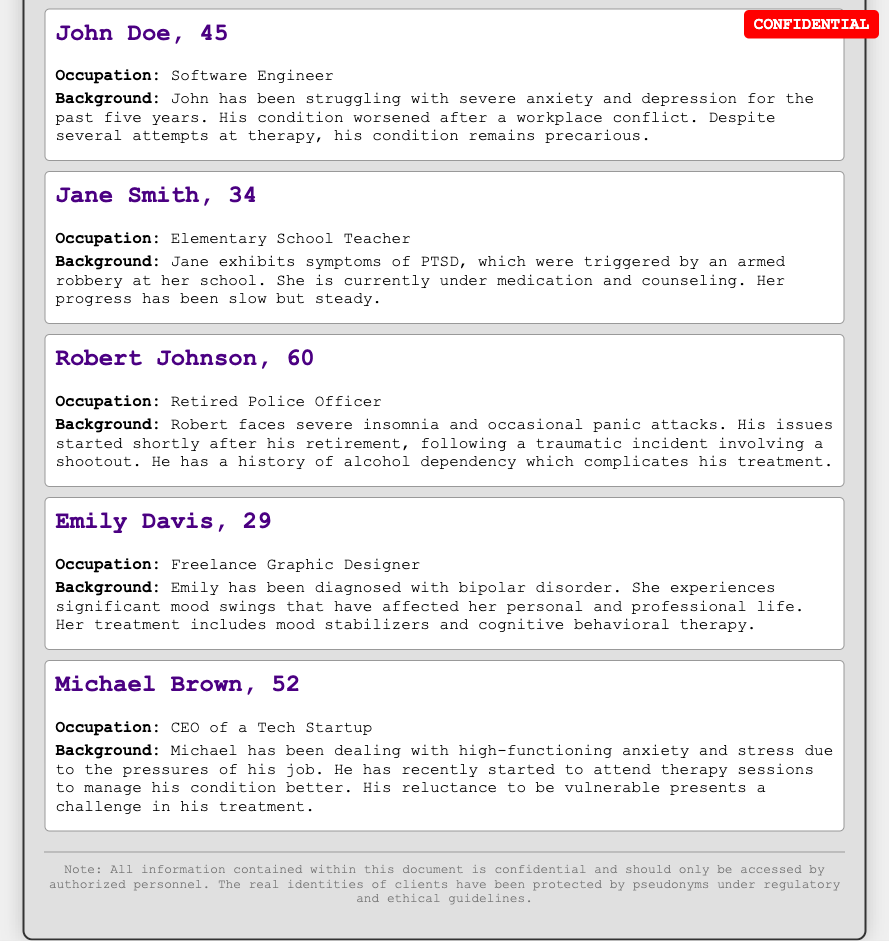what is the occupation of John Doe? John Doe's occupation is listed in the document as a Software Engineer.
Answer: Software Engineer how old is Jane Smith? The document states that Jane Smith is 34 years old.
Answer: 34 what mental health diagnosis does Emily Davis have? The document reveals that Emily Davis has been diagnosed with bipolar disorder.
Answer: bipolar disorder what triggered Jane Smith's PTSD? The document explains that Jane's PTSD was triggered by an armed robbery at her school.
Answer: armed robbery how many clients are mentioned in the document? The document includes a total of five clients listed in the confidential client list.
Answer: five which client has a history of alcohol dependency? Robert Johnson is the client who has a history of alcohol dependency according to the document.
Answer: Robert Johnson what progress has Jane Smith made in her treatment? The document states that Jane's progress has been slow but steady.
Answer: slow but steady what is the main challenge in Michael Brown's treatment? The document indicates that Michael's reluctance to be vulnerable presents a challenge in his treatment.
Answer: reluctance to be vulnerable what is the notable condition of Robert Johnson post-retirement? According to the document, Robert faces severe insomnia following his retirement.
Answer: severe insomnia 